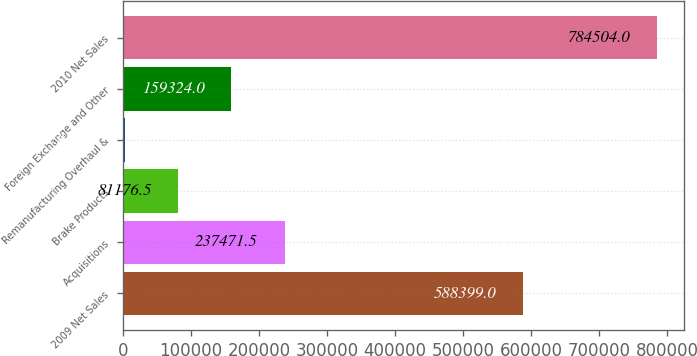Convert chart to OTSL. <chart><loc_0><loc_0><loc_500><loc_500><bar_chart><fcel>2009 Net Sales<fcel>Acquisitions<fcel>Brake Products<fcel>Remanufacturing Overhaul &<fcel>Foreign Exchange and Other<fcel>2010 Net Sales<nl><fcel>588399<fcel>237472<fcel>81176.5<fcel>3029<fcel>159324<fcel>784504<nl></chart> 